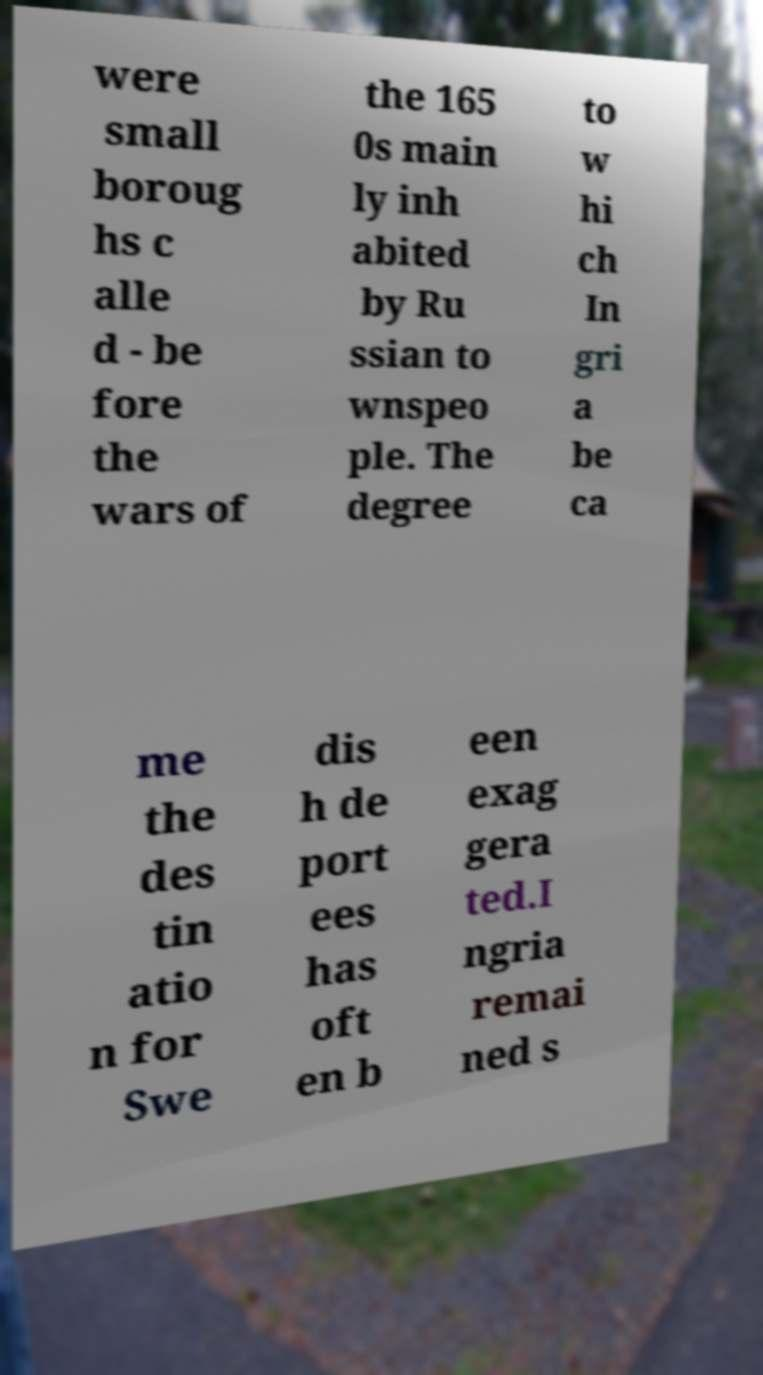There's text embedded in this image that I need extracted. Can you transcribe it verbatim? were small boroug hs c alle d - be fore the wars of the 165 0s main ly inh abited by Ru ssian to wnspeo ple. The degree to w hi ch In gri a be ca me the des tin atio n for Swe dis h de port ees has oft en b een exag gera ted.I ngria remai ned s 